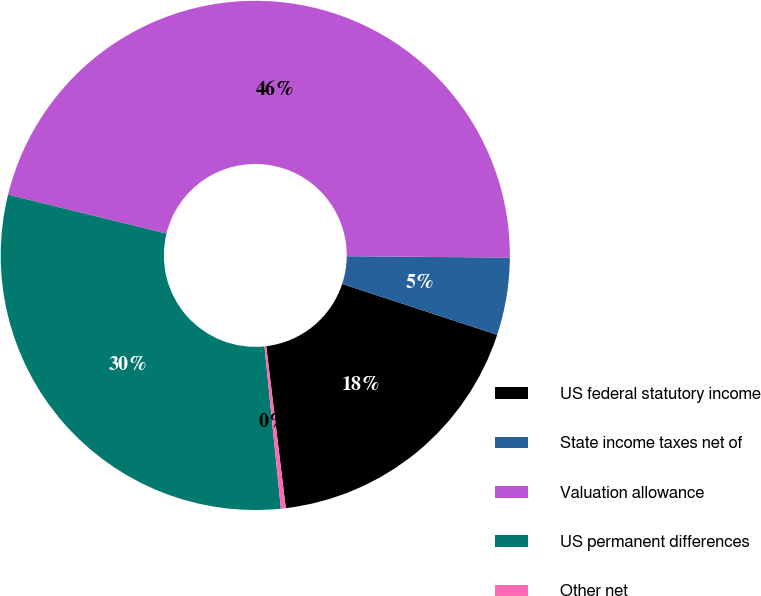<chart> <loc_0><loc_0><loc_500><loc_500><pie_chart><fcel>US federal statutory income<fcel>State income taxes net of<fcel>Valuation allowance<fcel>US permanent differences<fcel>Other net<nl><fcel>18.04%<fcel>4.91%<fcel>46.31%<fcel>30.43%<fcel>0.31%<nl></chart> 